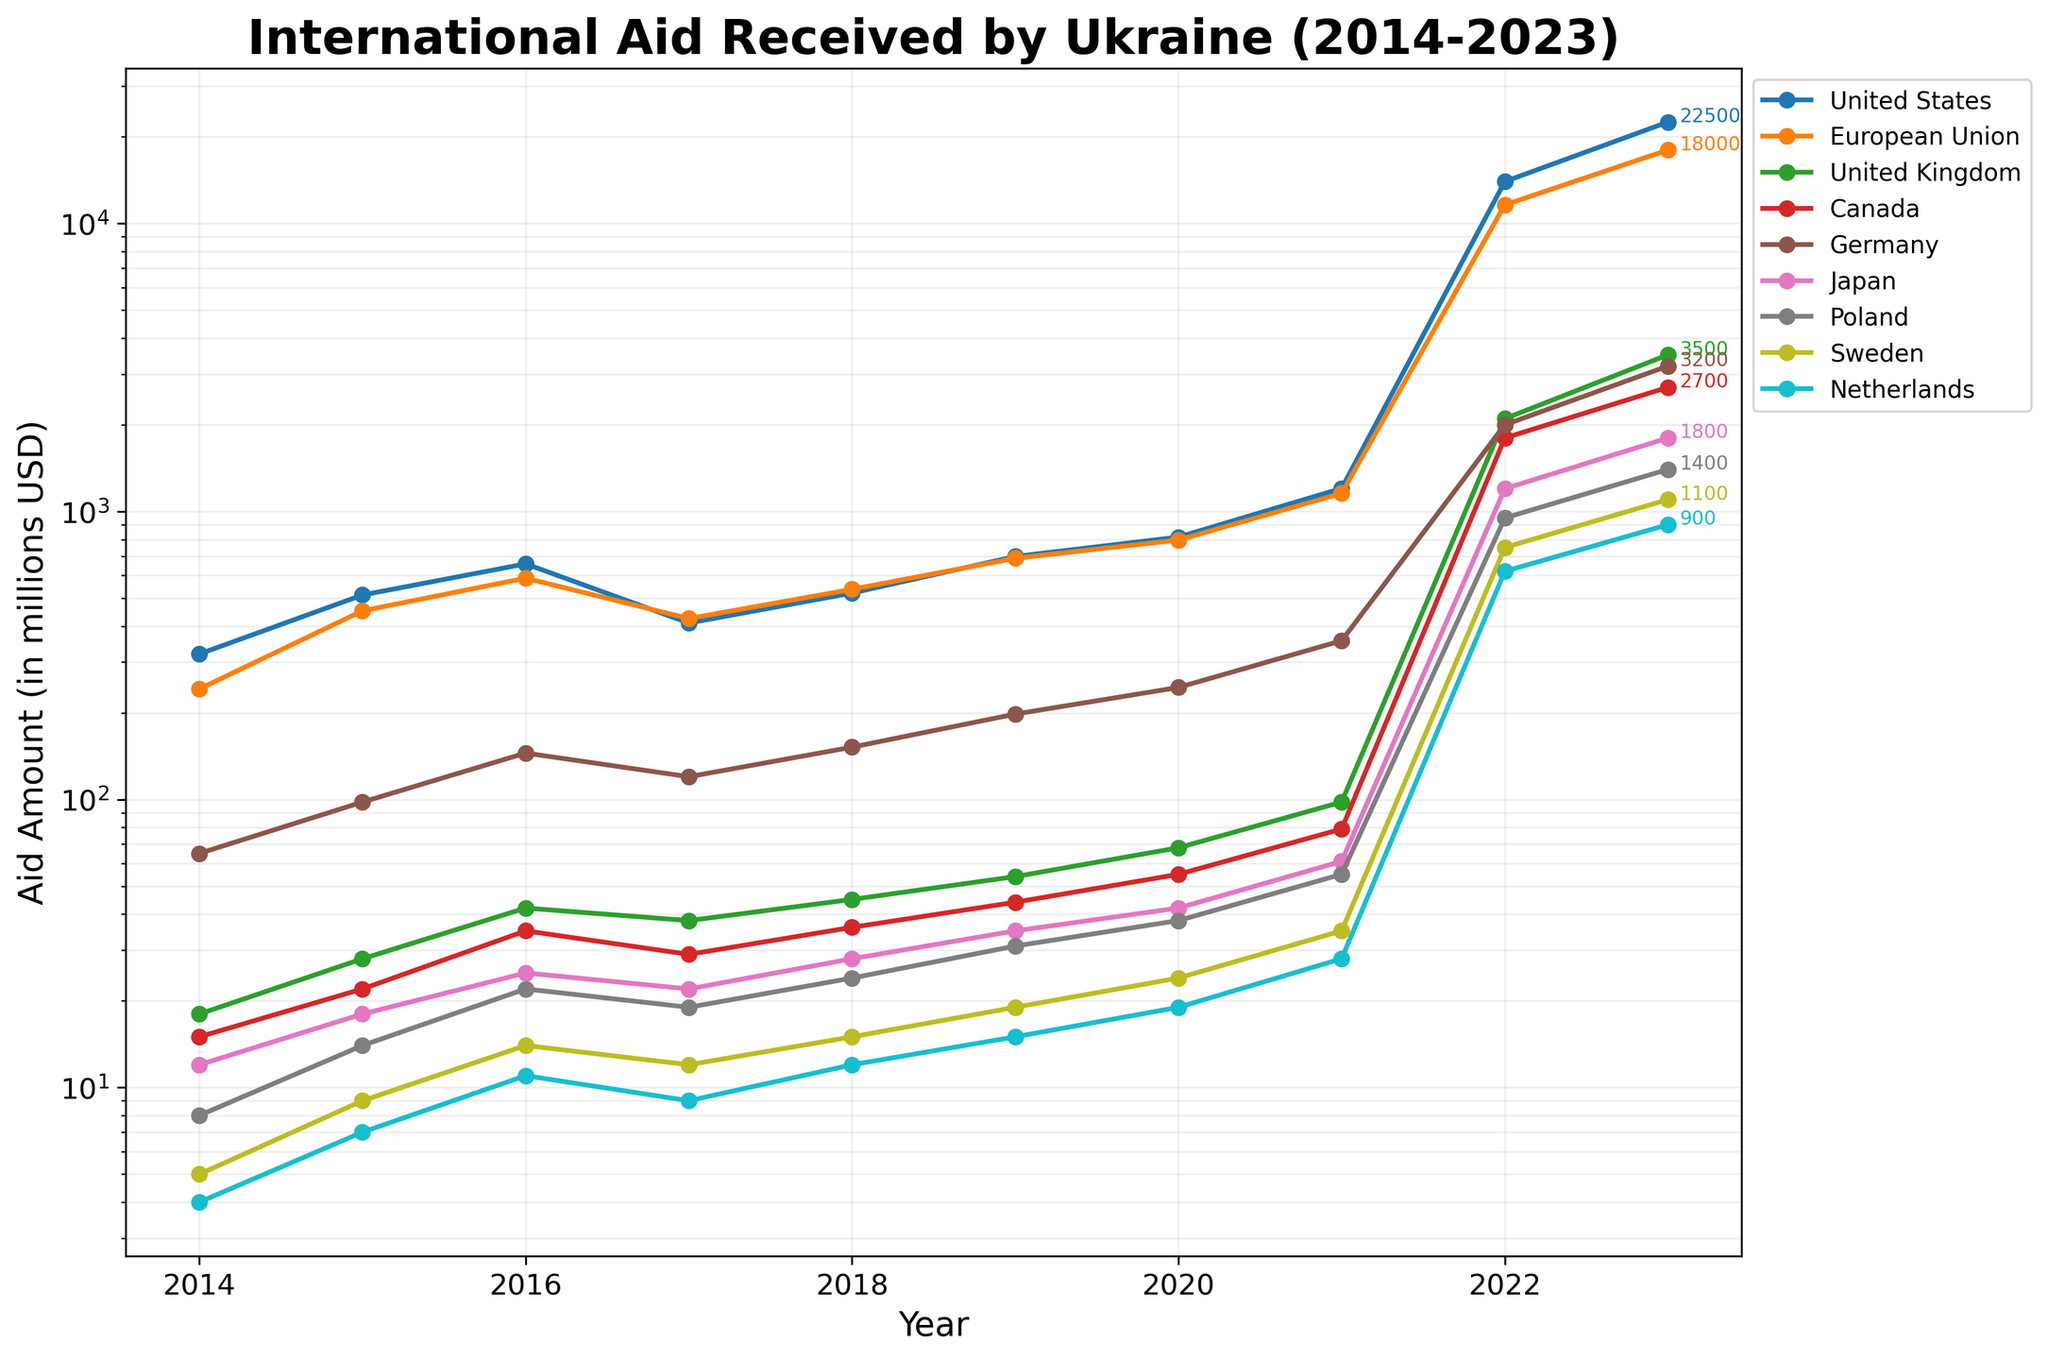What's the difference in aid between the United States and the European Union in 2023? To find the difference, identify the aid amounts for both the United States and the European Union in 2023 (22500 and 18000 respectively). Subtract the European Union's aid from the United States' aid: 22500 - 18000 = 4500
Answer: 4500 Which country provided the highest aid in 2022? The highest aid in 2022 can be found by examining the aid amounts for all countries in 2022. The United States provided 13980 million USD, which is the highest compared to other countries
Answer: United States What was the total aid received by Ukraine from Poland from 2014 to 2023? To find the total, sum all the annual aid amounts provided by Poland from 2014 to 2023 (8+14+22+19+24+31+38+55+950+1400). The total is 2561
Answer: 2561 In which year did Germany provide the least aid, and what was the amount? Look through the yearly aid amounts given by Germany. In 2014, Germany provided the least aid amounting to 65 million USD
Answer: 2014, 65 What's the sum of the aid provided by the United Kingdom and Canada in 2020? Identify the aid amounts for the United Kingdom and Canada in 2020 (68 and 55 respectively). Sum them up: 68 + 55 = 123
Answer: 123 From 2014 to 2023, which year saw the largest increase in aid from the European Union, and what was the difference? Calculate the differences in aid received from the European Union year over year. The largest increase was from 2021 to 2022, with the difference being 11600 - 1156 = 10444
Answer: 2022, 10444 How many countries provided more than 5000 million USD in aid in 2023? Examine each country's aid amount in 2023. Only the United States (22500) and the European Union (18000) exceed 5000 million USD. Hence, the count is 2
Answer: 2 What's the average aid amount provided by Sweden between 2014 and 2023? To find the average, sum the aid amounts provided by Sweden from 2014 to 2023 (5+9+14+12+15+19+24+35+750+1100) and divide by the number of years (10): (5+9+14+12+15+19+24+35+750+1100) / 10 = 1983 / 10 = 198.3
Answer: 198.3 Was there any year where the aid provided by Canada remained the same as the previous year? Review the aid amounts for Canada year over year. It increases each year; therefore, there was no year when the aid remained the same
Answer: No What trend is observed in the aid provided by Japan from 2014 to 2023? Observe the aid amounts for Japan from 2014 to 2023. There's a gradual increase over the years, except for a large jump in 2022 and 2023
Answer: Gradual increase with a large jump in 2022 and 2023 